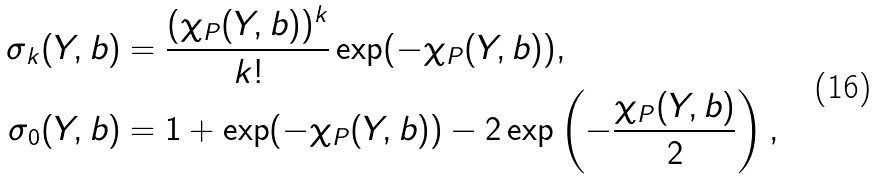<formula> <loc_0><loc_0><loc_500><loc_500>\sigma _ { k } ( Y , b ) & = \frac { ( \chi _ { P } ( Y , b ) ) ^ { k } } { k ! } \exp ( - \chi _ { P } ( Y , b ) ) , \\ \sigma _ { 0 } ( Y , b ) & = 1 + \exp ( - \chi _ { P } ( Y , b ) ) - 2 \exp \left ( - \frac { \chi _ { P } ( Y , b ) } { 2 } \right ) ,</formula> 